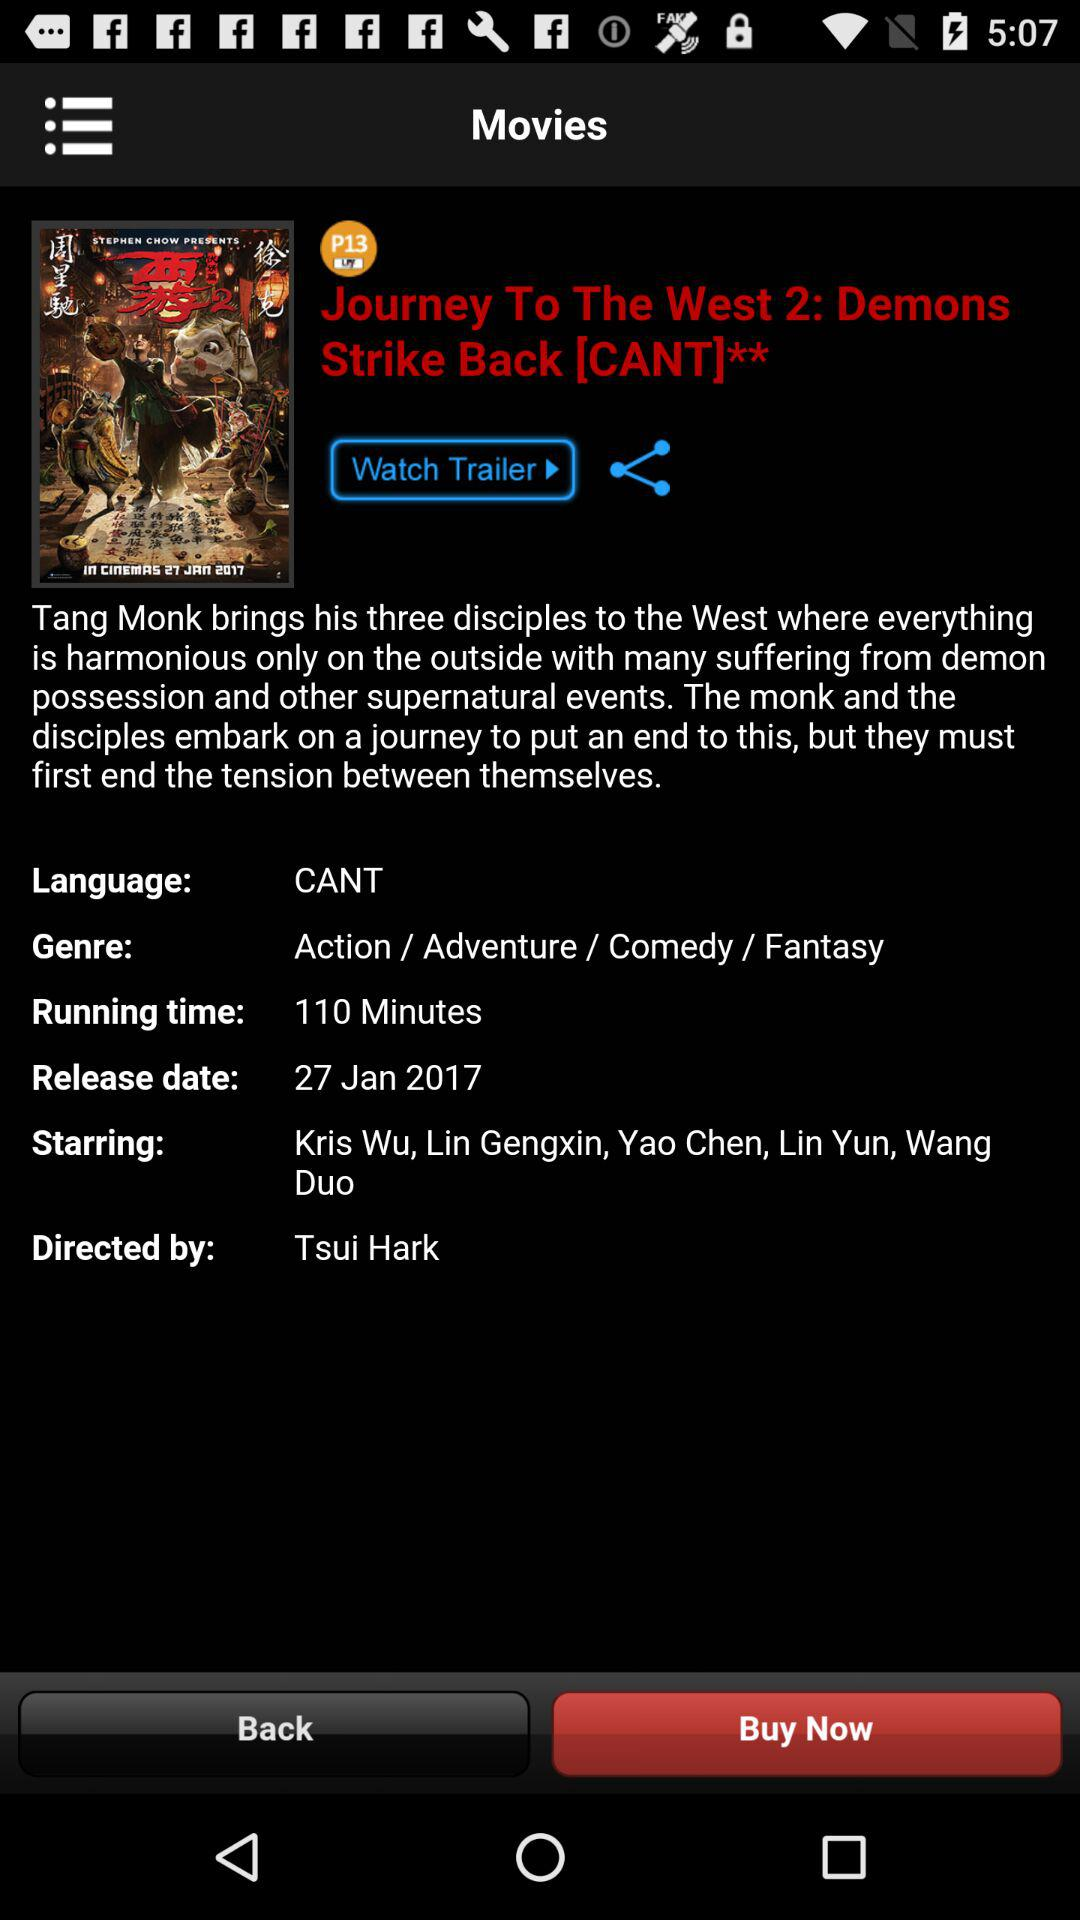What is the name of the movie? The name of the movie is "Journey To The West 2: Demons Strike Back [CANT]**". 